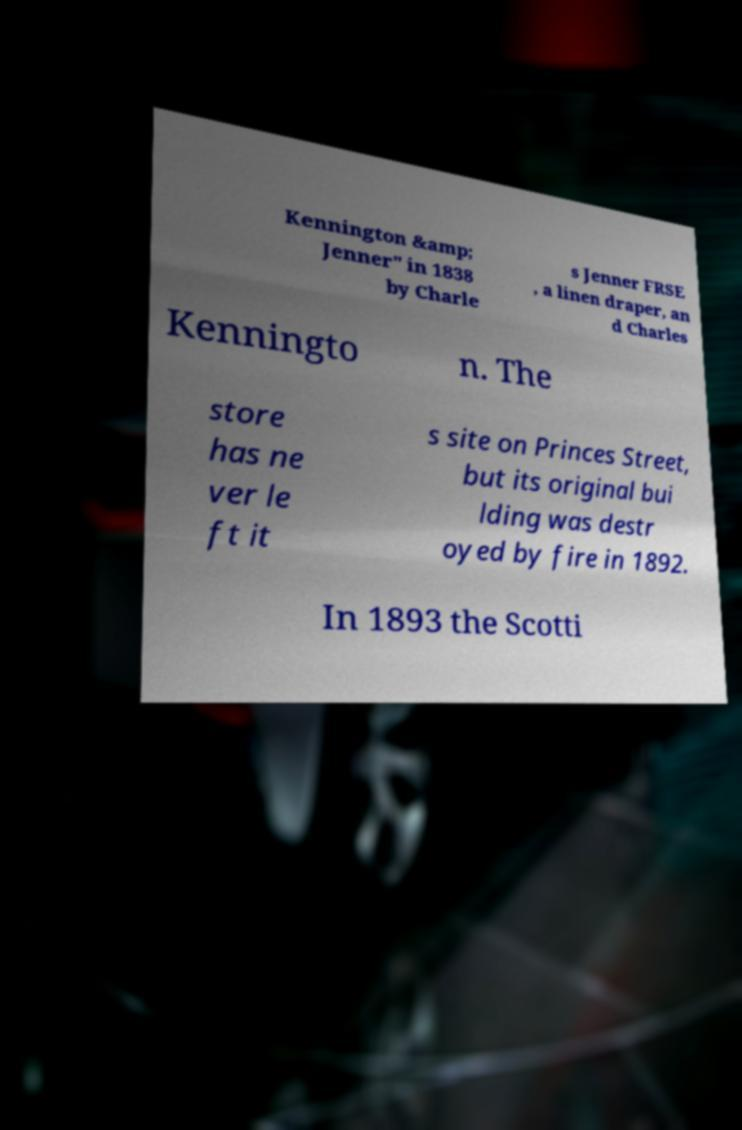There's text embedded in this image that I need extracted. Can you transcribe it verbatim? Kennington &amp; Jenner" in 1838 by Charle s Jenner FRSE , a linen draper, an d Charles Kenningto n. The store has ne ver le ft it s site on Princes Street, but its original bui lding was destr oyed by fire in 1892. In 1893 the Scotti 